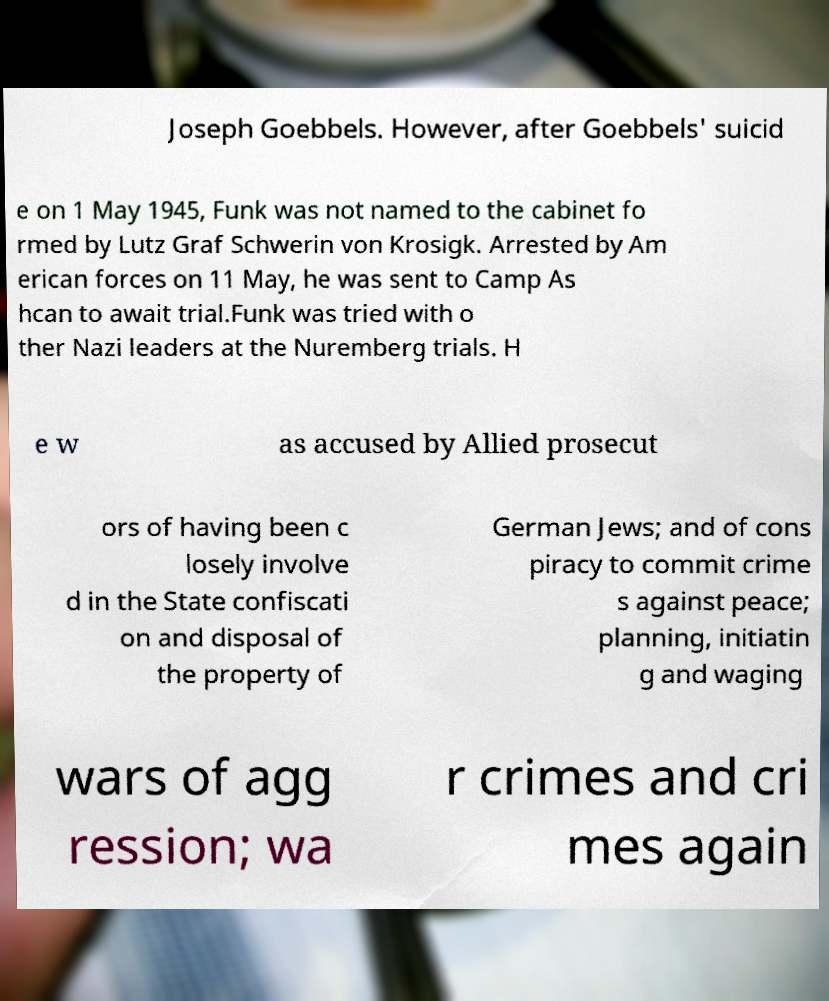Could you assist in decoding the text presented in this image and type it out clearly? Joseph Goebbels. However, after Goebbels' suicid e on 1 May 1945, Funk was not named to the cabinet fo rmed by Lutz Graf Schwerin von Krosigk. Arrested by Am erican forces on 11 May, he was sent to Camp As hcan to await trial.Funk was tried with o ther Nazi leaders at the Nuremberg trials. H e w as accused by Allied prosecut ors of having been c losely involve d in the State confiscati on and disposal of the property of German Jews; and of cons piracy to commit crime s against peace; planning, initiatin g and waging wars of agg ression; wa r crimes and cri mes again 